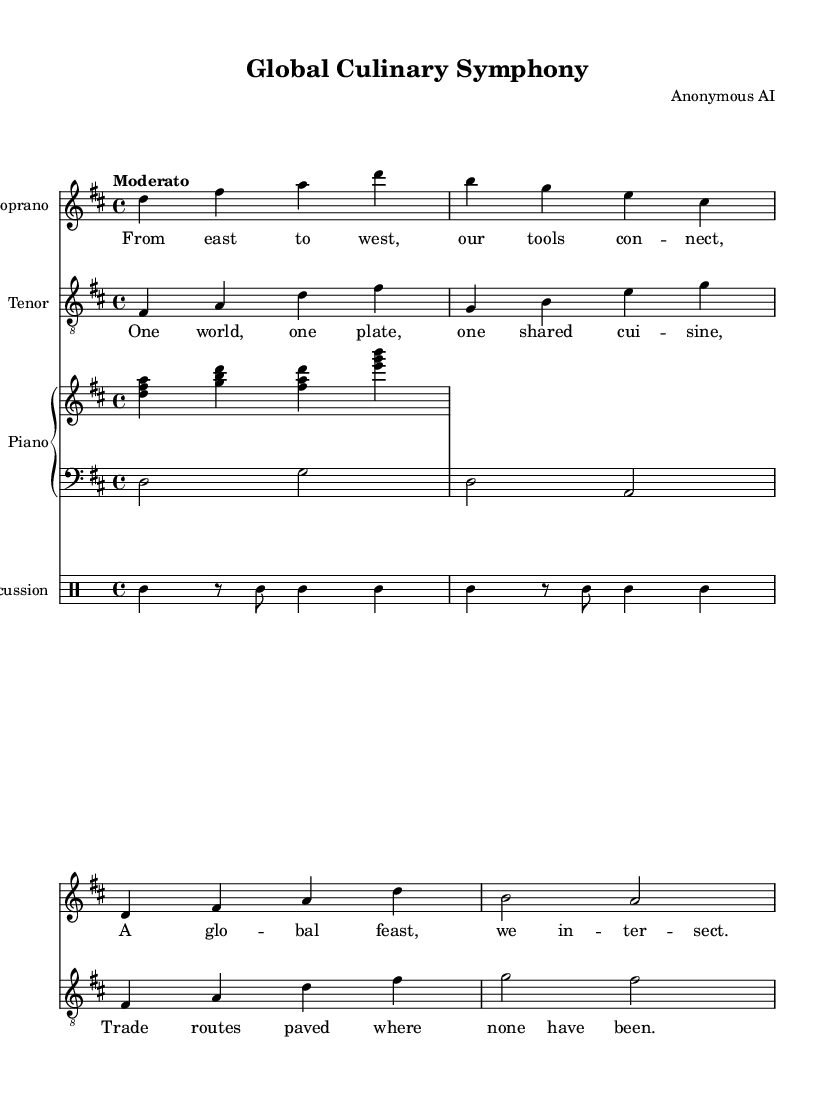What is the key signature of this music? The key signature is D major, which has two sharps (F# and C#). This can be determined by looking at the key signature indicated at the beginning of the score.
Answer: D major What is the time signature of the piece? The time signature is 4/4, indicating four beats per measure. This is found at the beginning of the score, just after the key signature.
Answer: 4/4 What is the tempo marking for this piece? The tempo marking is "Moderato," which suggests a moderate pace. This is explicitly stated in the score underneath the global settings.
Answer: Moderato How many measures are in the soprano part? The soprano part contains four measures, which can be counted by looking at the notation and the bar lines separating the measures in the staff.
Answer: 4 What is the main theme expressed in the lyrics? The main theme revolves around globalization and shared culinary experiences, as illustrated by the lyrics of the verse and chorus that mention connecting tools and shared cuisine. This thematic content is extracted from the words provided in the lyric section of the score.
Answer: Global feast What instrument plays the bass clef? The instrument that plays the bass clef in this score is the piano, specifically in the left hand part, which typically reads from the bass staff. This can be observed in the PianoStaff section of the score where the left hand is denoted with a bass clef.
Answer: Piano Which voice is indicated to sing the tenor part? The tenor part is designated to be sung by the tenor voice, indicated in the score where the staff is labeled "Tenor." This means the part is specifically written for a tenor singer.
Answer: Tenor 